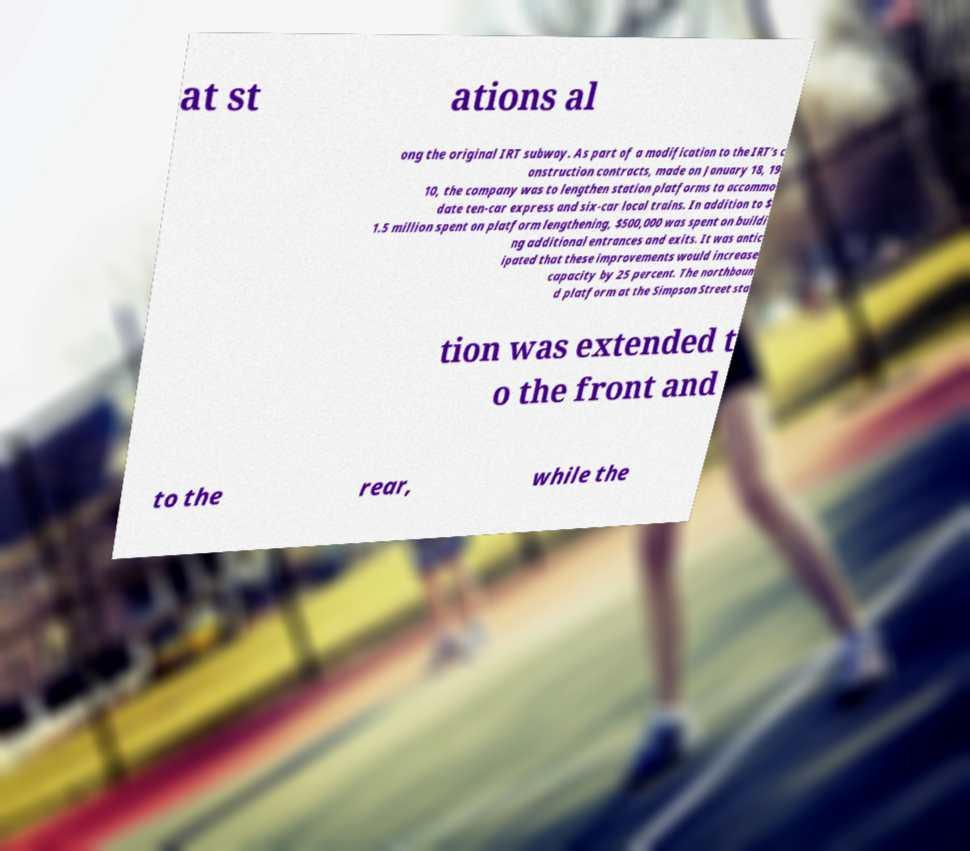Could you assist in decoding the text presented in this image and type it out clearly? at st ations al ong the original IRT subway. As part of a modification to the IRT's c onstruction contracts, made on January 18, 19 10, the company was to lengthen station platforms to accommo date ten-car express and six-car local trains. In addition to $ 1.5 million spent on platform lengthening, $500,000 was spent on buildi ng additional entrances and exits. It was antic ipated that these improvements would increase capacity by 25 percent. The northboun d platform at the Simpson Street sta tion was extended t o the front and to the rear, while the 